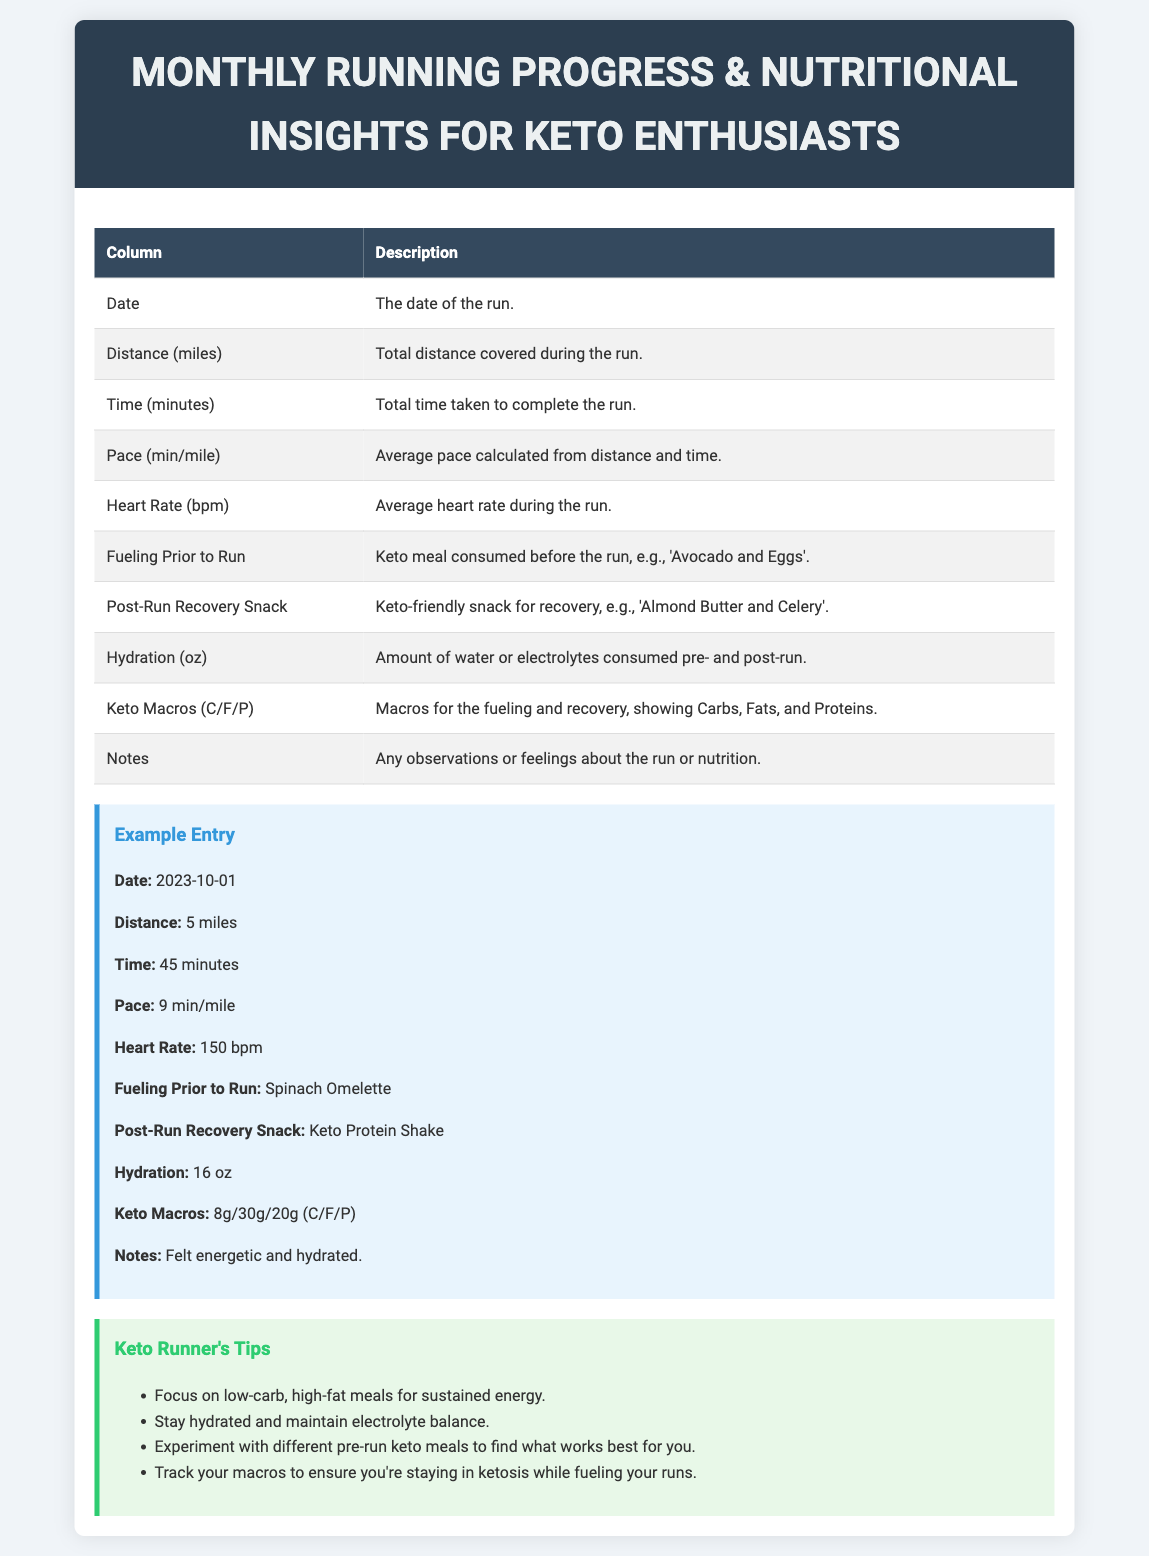What is the title of the document? The title is the main heading in the header section of the document.
Answer: Monthly Running Progress & Nutritional Insights for Keto Enthusiasts How many columns are in the table? The table has two columns: one for "Column" and one for "Description."
Answer: 2 What is the example distance covered in the entry? The example entry specifies the distance covered during the run.
Answer: 5 miles What is the average heart rate during the example run? The example entry includes the average heart rate as part of the recorded statistics.
Answer: 150 bpm What is the post-run recovery snack in the example? The post-run recovery snack is indicated in the example entry for nutritional insights.
Answer: Keto Protein Shake What does "Keto Macros (C/F/P)" stand for? This term is explained in the table as showing Carbs, Fats, and Proteins.
Answer: Carbs, Fats, and Proteins How many tips for keto runners are mentioned? The document lists tips in a bullet point format under a specific section.
Answer: 4 What should you focus on for sustained energy according to the tips? The tips section contains recommendations for dietary focus based on keto principles.
Answer: Low-carb, high-fat meals What hydration amount is listed in the example entry? The example entry includes a specific value for hydration.
Answer: 16 oz 